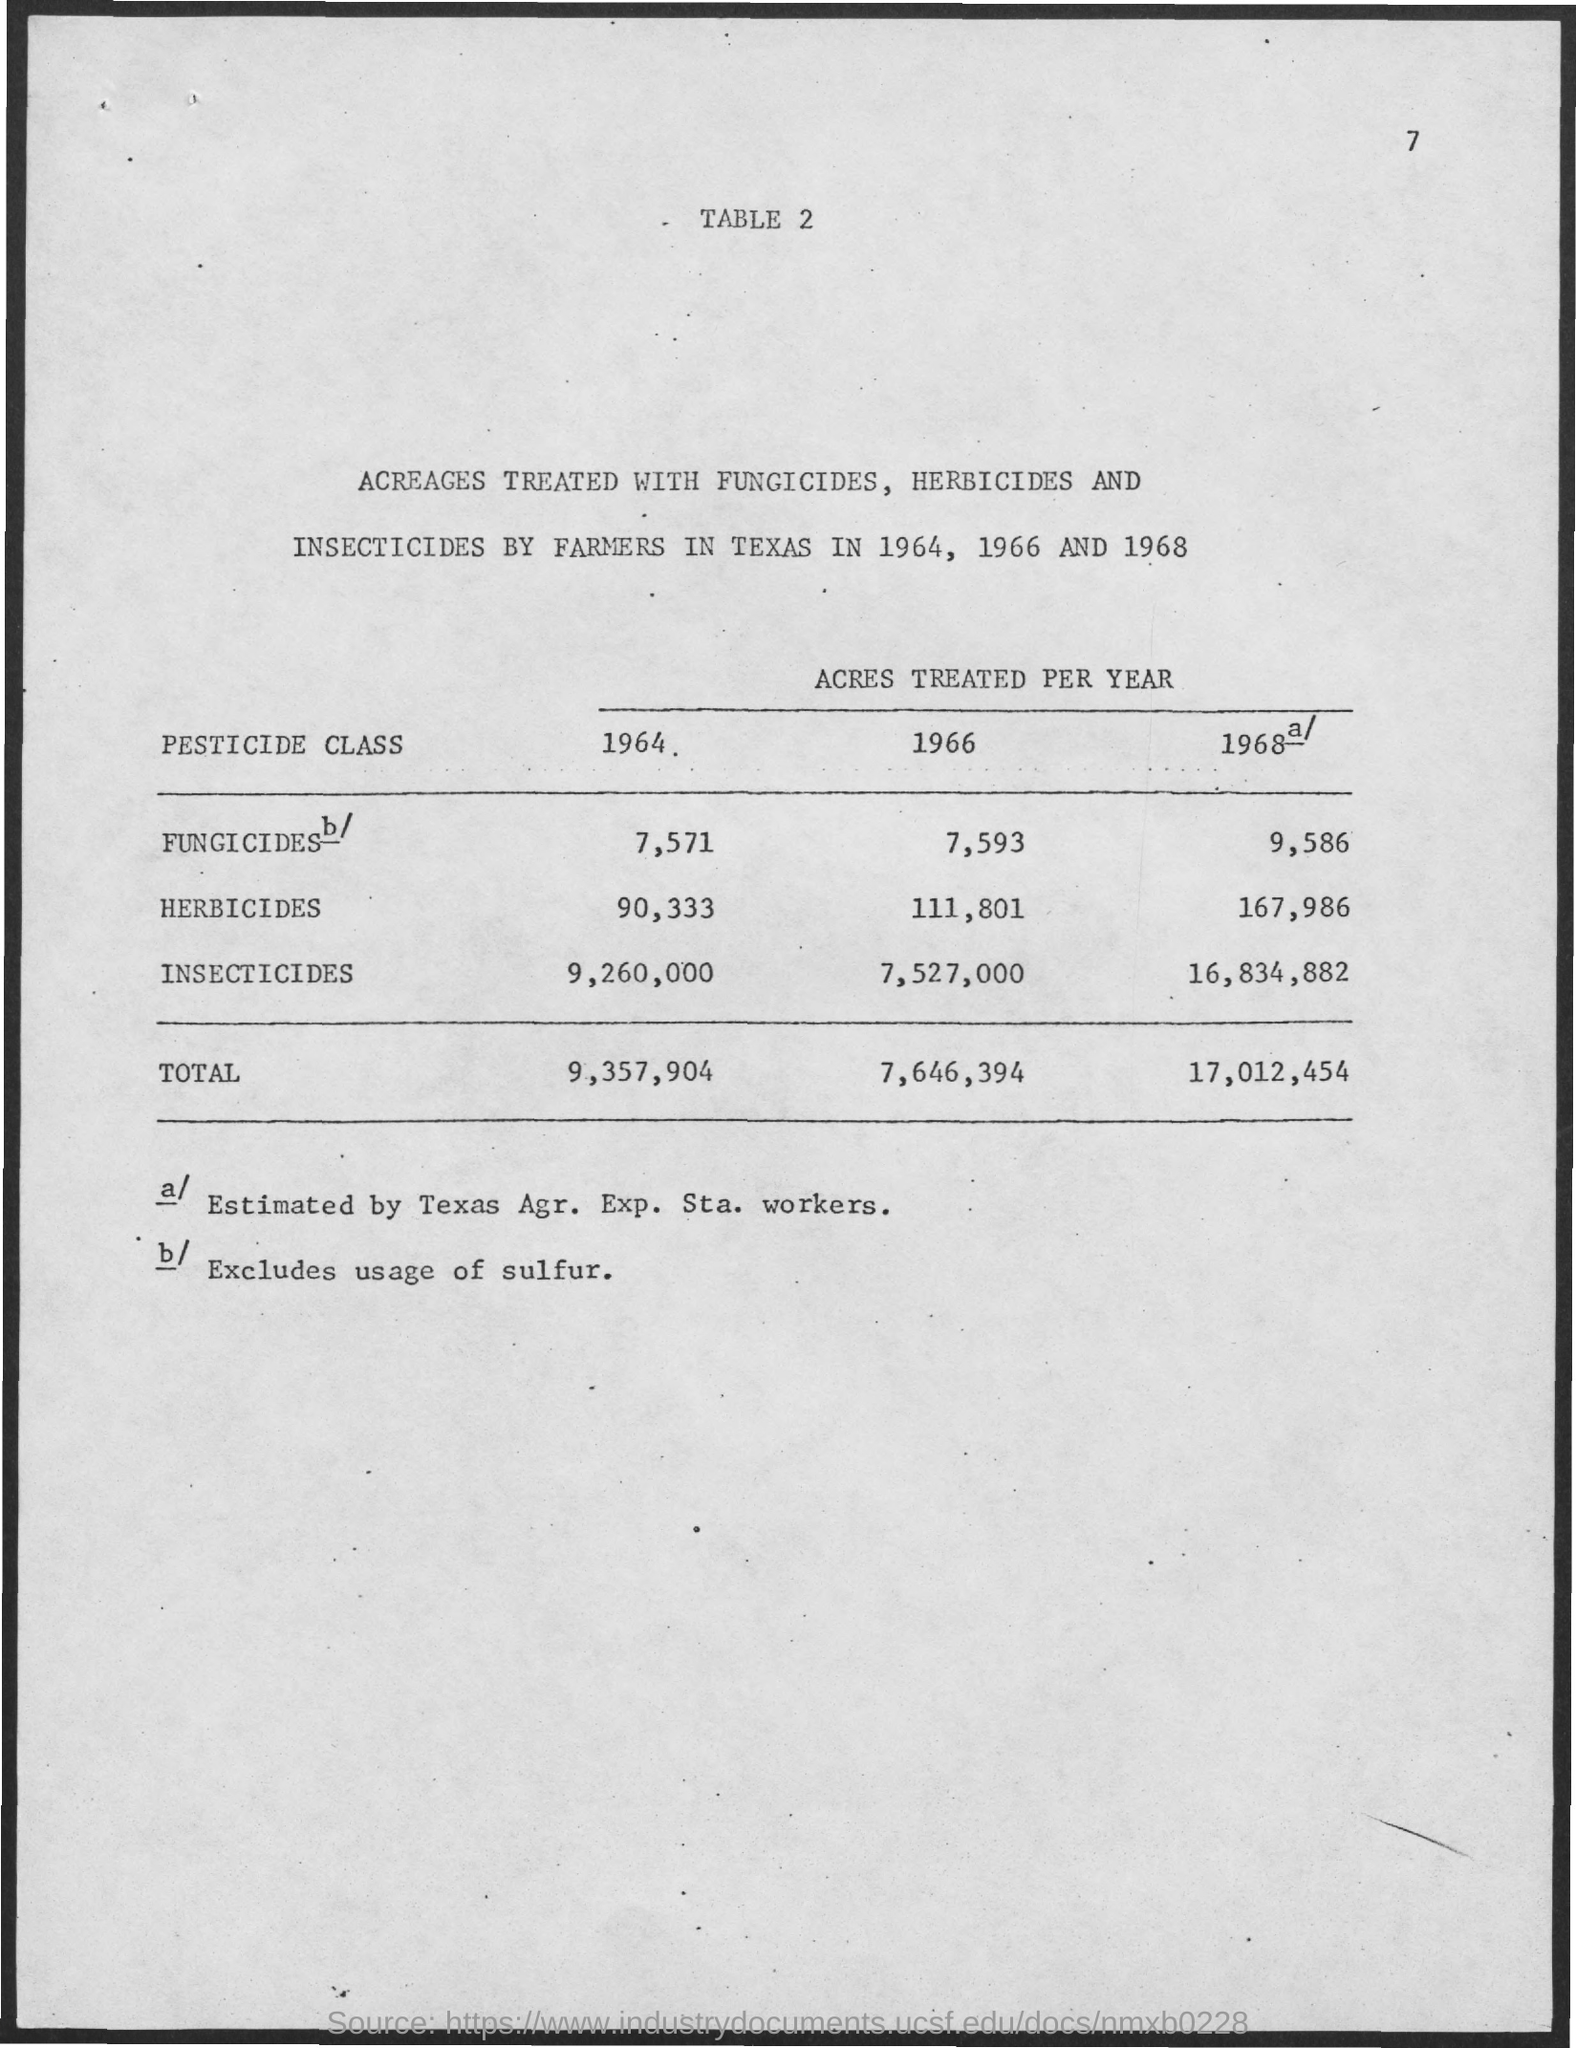Highlight a few significant elements in this photo. In the year 1964, a total of 90,333 acres were treated with herbicides. In the year 1966, a total of 7,646,394 acres were treated. In 1968, the total acres treated with different pesticides was larger than in any other year. 